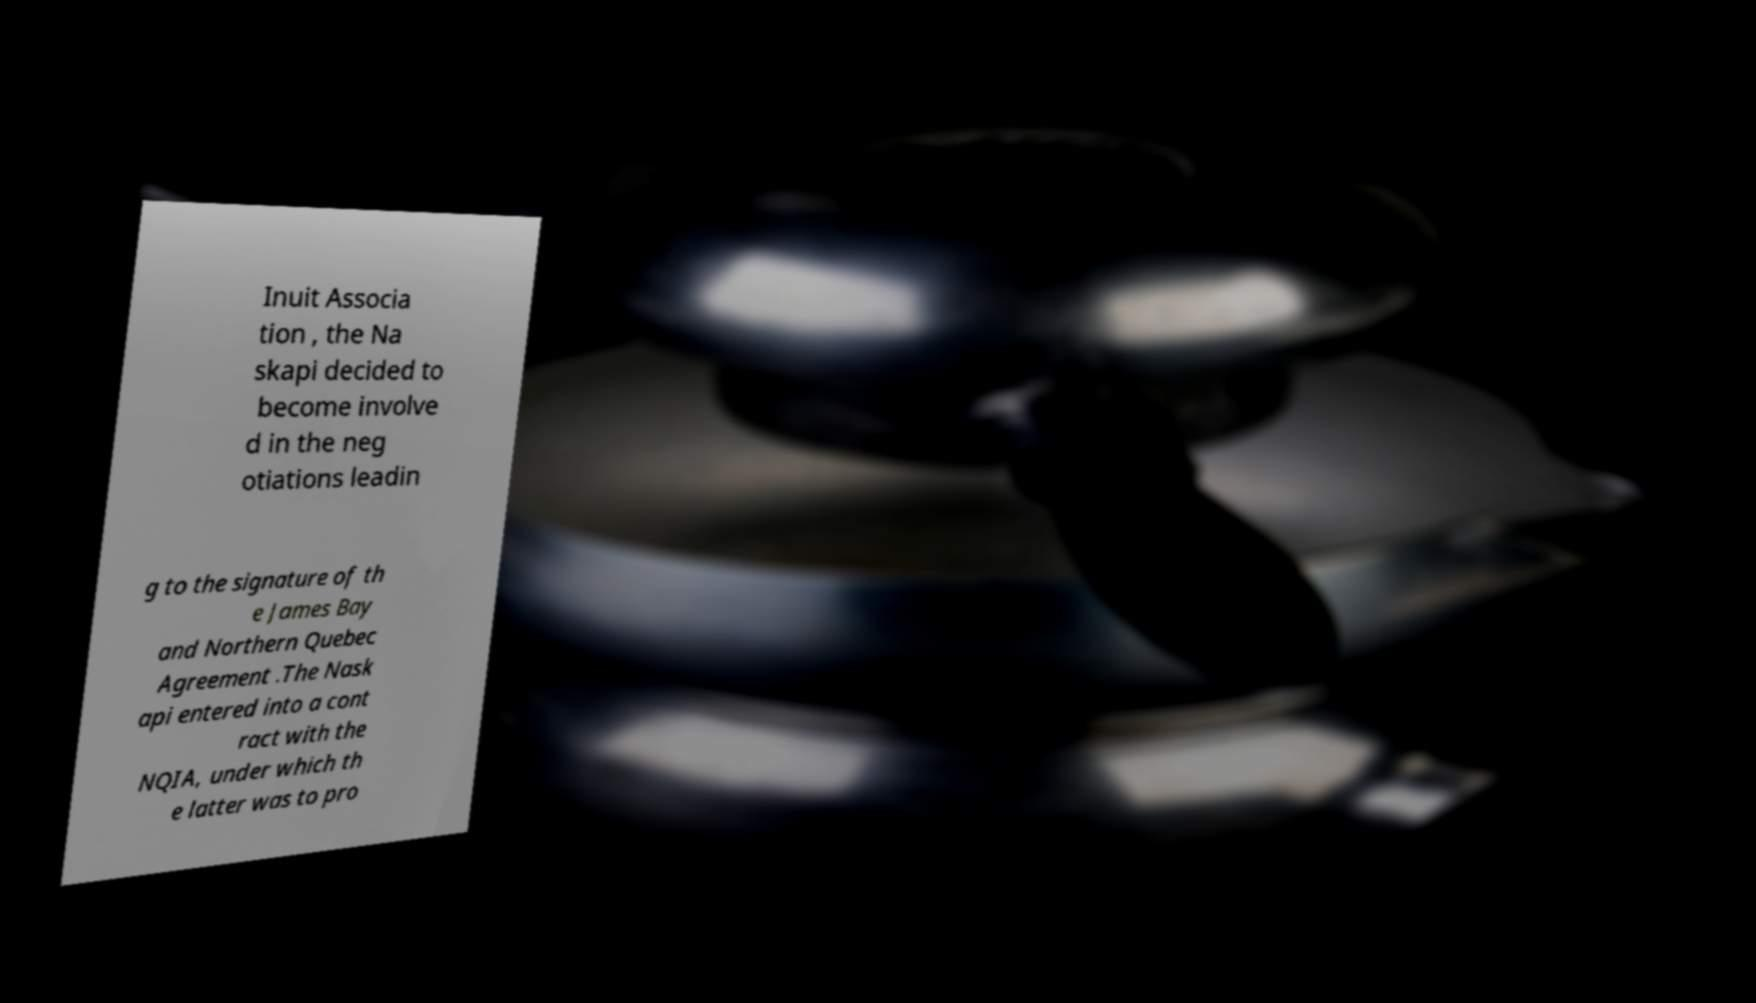Please identify and transcribe the text found in this image. Inuit Associa tion , the Na skapi decided to become involve d in the neg otiations leadin g to the signature of th e James Bay and Northern Quebec Agreement .The Nask api entered into a cont ract with the NQIA, under which th e latter was to pro 